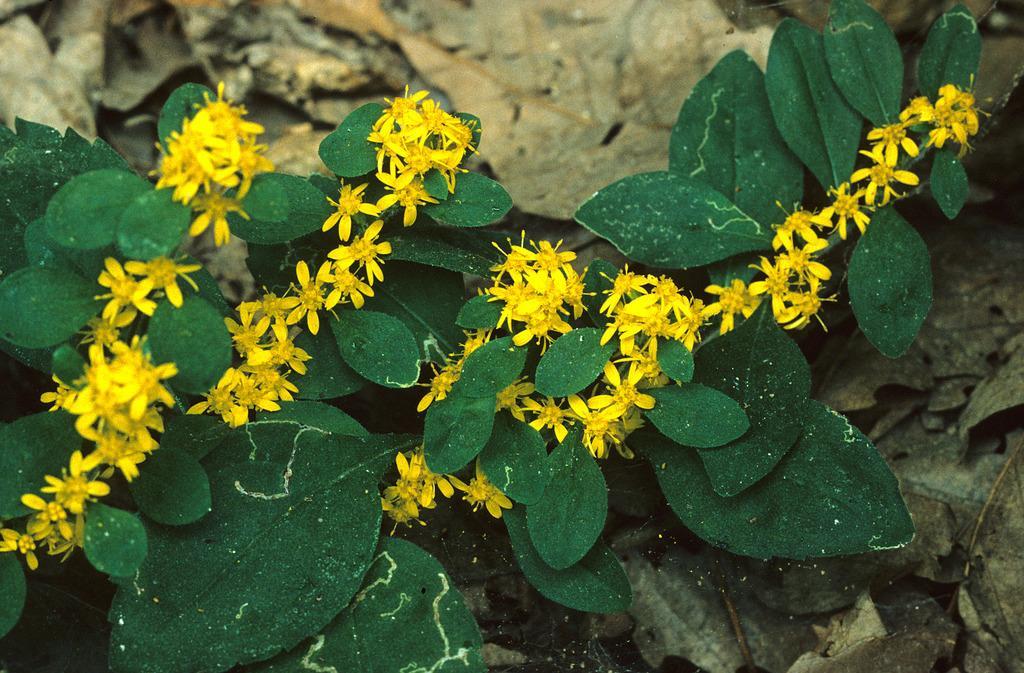In one or two sentences, can you explain what this image depicts? In this picture we can see dried leaves, green leaves and yellow flowers. 